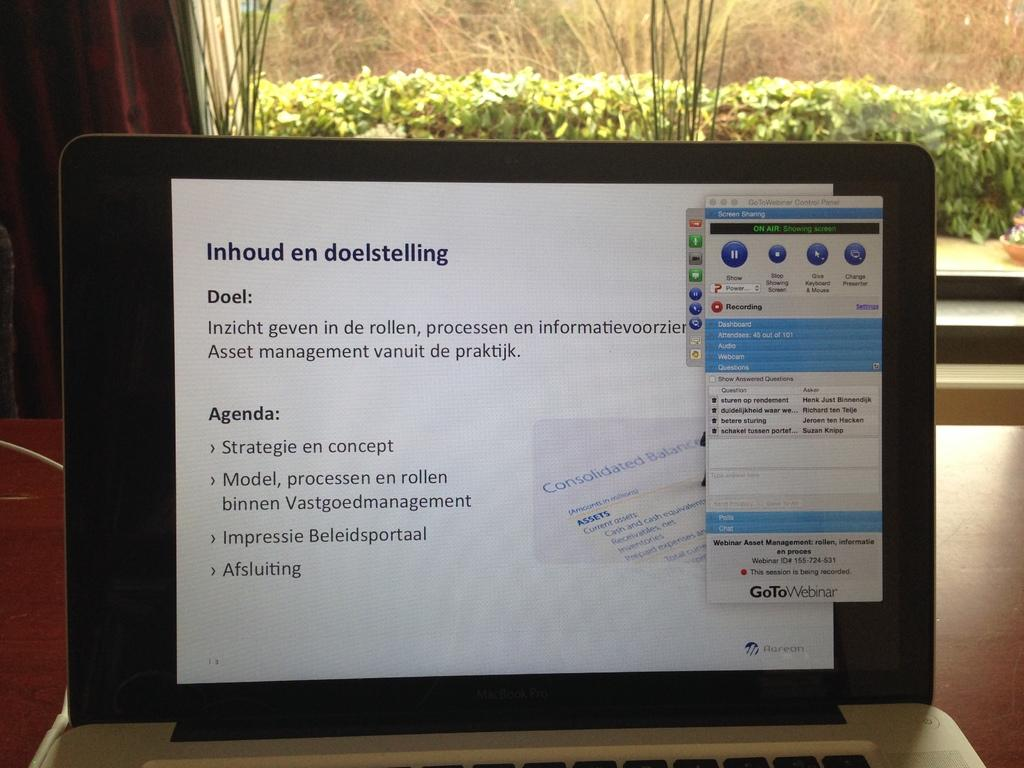<image>
Describe the image concisely. a macbook screen with a page open that is titled 'inhound en doelstelling' 